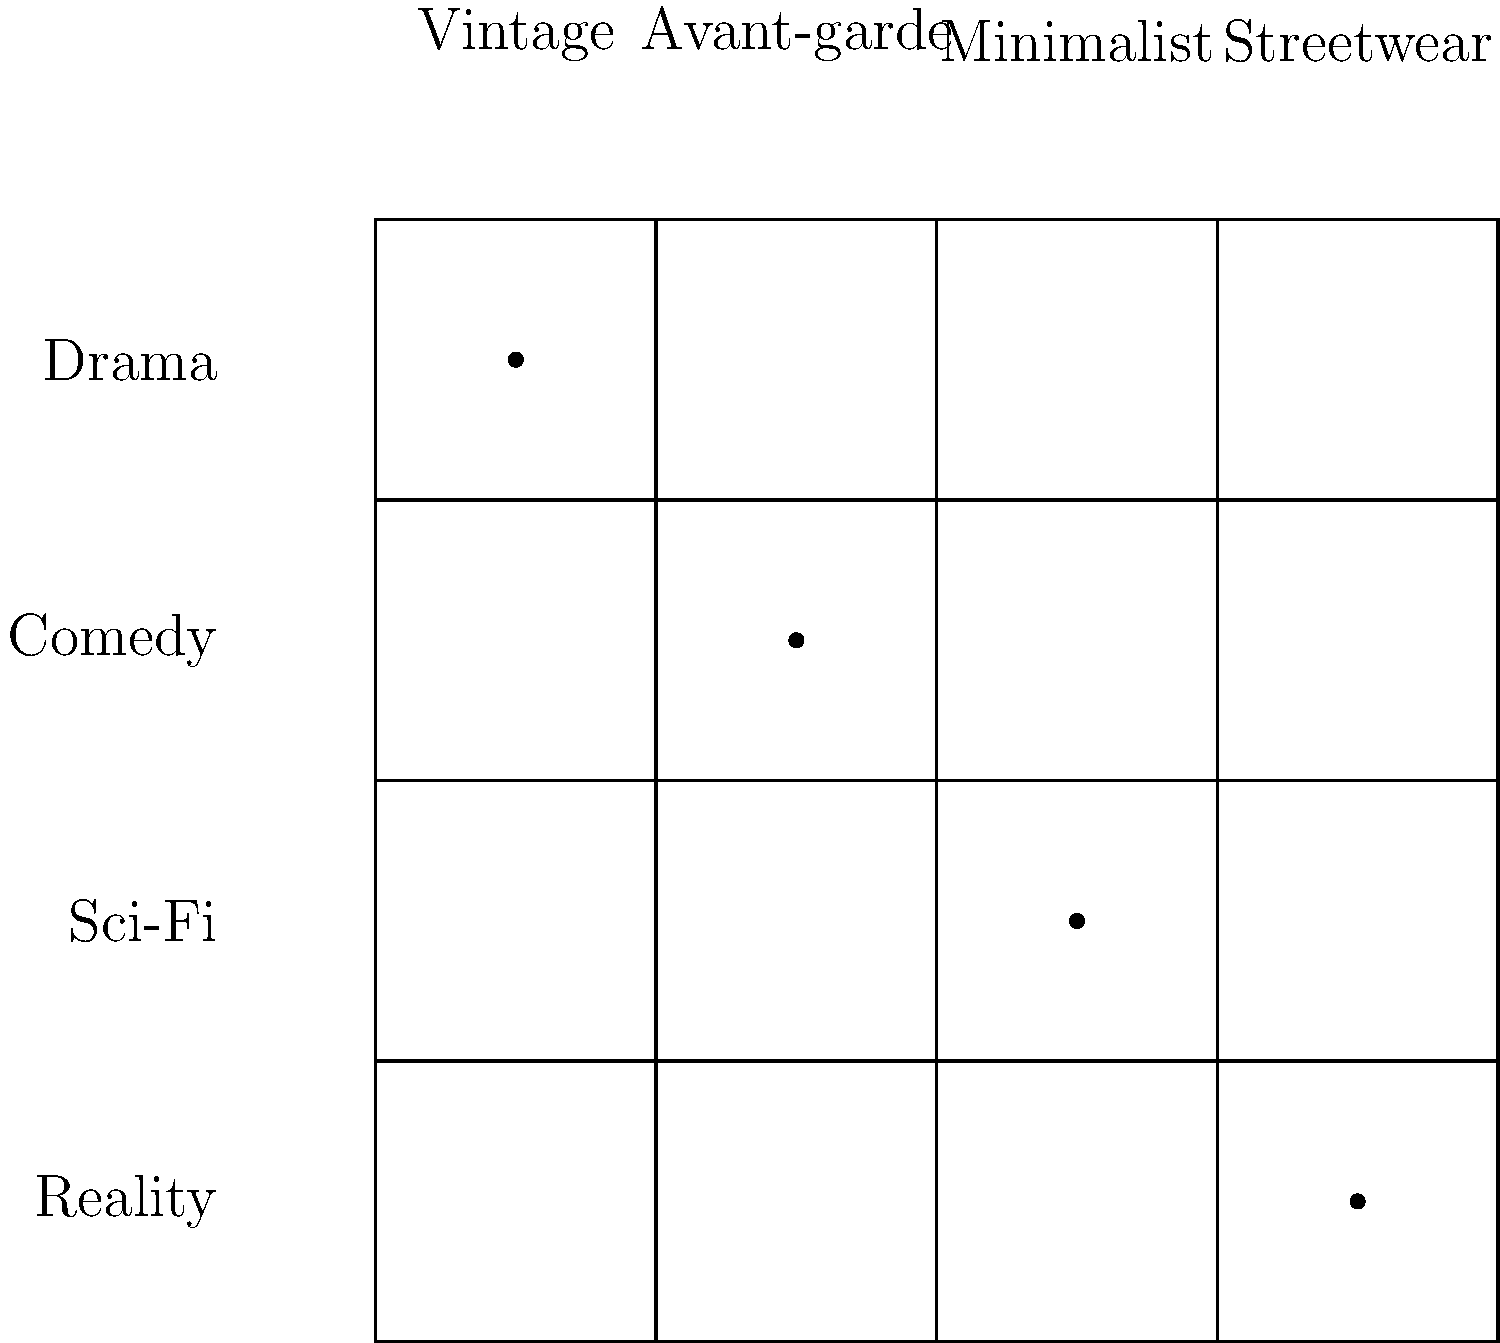Based on the grid showing the relationship between TV show genres and fashion styles, which fashion style would be most appropriate for a new sci-fi series aiming to create a futuristic aesthetic? To determine the most appropriate fashion style for a new sci-fi series with a futuristic aesthetic, let's analyze the grid:

1. The grid shows four TV show genres (Drama, Comedy, Sci-Fi, Reality) and four fashion styles (Vintage, Avant-garde, Minimalist, Streetwear).

2. Each genre is matched with a specific fashion style, as indicated by the dots in the grid.

3. For the Sci-Fi genre, we can see that it's matched with the Minimalist fashion style.

4. This pairing makes sense for a futuristic aesthetic because:
   a) Minimalist design often emphasizes clean lines, simplicity, and functionality.
   b) These characteristics align well with common depictions of future settings in sci-fi, where technology and efficiency are prioritized.
   c) Minimalist fashion can easily convey a sense of advanced technology and streamlined living often associated with futuristic scenarios.

5. The other styles wouldn't be as suitable:
   a) Vintage is more associated with historical or period dramas.
   b) Avant-garde, while potentially futuristic, is matched with comedy in this grid.
   c) Streetwear is paired with reality shows and might not convey the desired futuristic aesthetic.

Therefore, based on the given grid and the goal of creating a futuristic aesthetic for a new sci-fi series, the most appropriate fashion style would be Minimalist.
Answer: Minimalist 